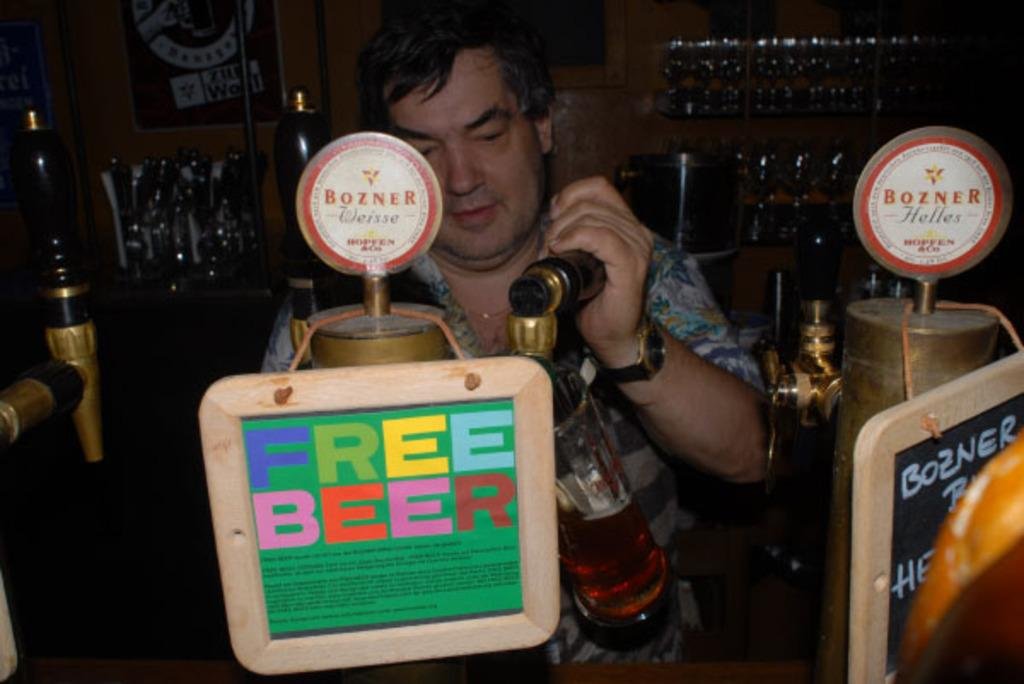Provide a one-sentence caption for the provided image. Man filling up beer behind a sign that says "Free Beer". 